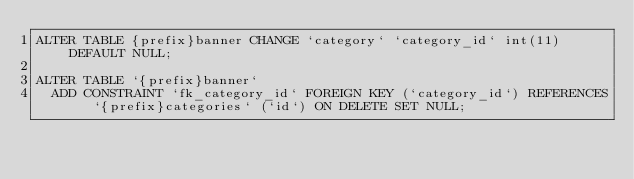Convert code to text. <code><loc_0><loc_0><loc_500><loc_500><_SQL_>ALTER TABLE {prefix}banner CHANGE `category` `category_id` int(11) DEFAULT NULL;

ALTER TABLE `{prefix}banner`
  ADD CONSTRAINT `fk_category_id` FOREIGN KEY (`category_id`) REFERENCES `{prefix}categories` (`id`) ON DELETE SET NULL;</code> 